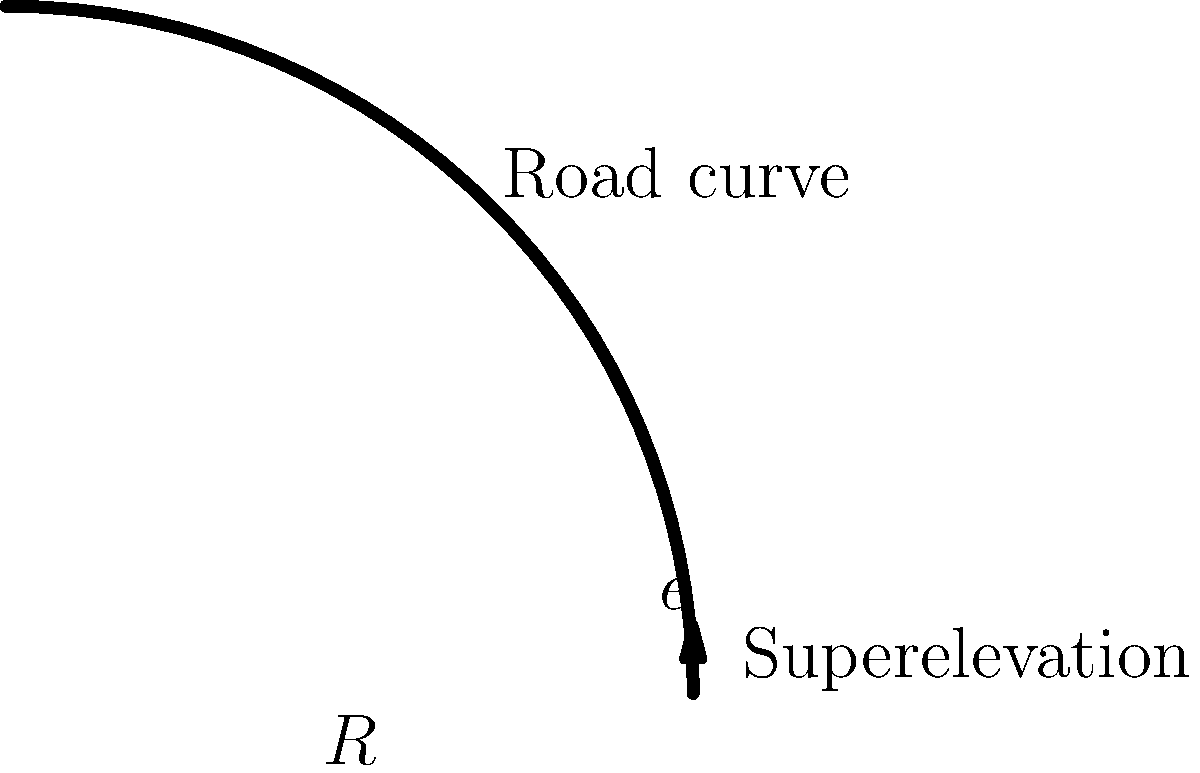You're designing a road curve for a new highway near Sydney that will connect fans to their favorite Georgia State Line concert venue. The design speed is 100 km/h, and the radius of the curve is 350 m. Using the Australian road design standards, which specify a maximum superelevation ($e$) of 6%, what is the minimum radius of curvature required for this design speed? To solve this problem, we'll use the formula for minimum radius of curvature, which balances the centrifugal force with the friction and superelevation:

$$R_{min} = \frac{V^2}{127(e + f)}$$

Where:
$R_{min}$ = minimum radius of curvature (m)
$V$ = design speed (km/h)
$e$ = superelevation rate (decimal)
$f$ = side friction factor

Steps:
1. Convert the design speed to m/s: 
   $V = 100 \text{ km/h} = 27.78 \text{ m/s}$

2. Determine the side friction factor ($f$) for 100 km/h. From Australian standards, $f = 0.11$ for this speed.

3. Use the maximum allowable superelevation, $e = 0.06$ (6%)

4. Apply the formula:

   $$R_{min} = \frac{(27.78)^2}{127(0.06 + 0.11)}$$
   
   $$R_{min} = \frac{771.73}{21.59} = 357.45 \text{ m}$$

5. Compare this to the given radius of 350 m. Since 357.45 m > 350 m, the given radius is slightly less than the minimum required.
Answer: 357.45 m 